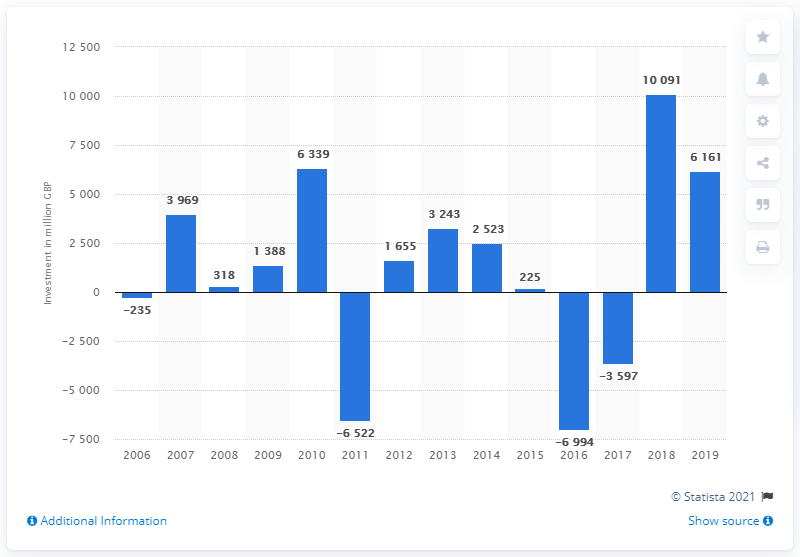Point out several critical features in this image. The highest amount of foreign direct investment in Africa in 2018 was 10,091. 